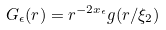Convert formula to latex. <formula><loc_0><loc_0><loc_500><loc_500>G _ { \epsilon } ( r ) = r ^ { - 2 x _ { \epsilon } } g ( r / \xi _ { 2 } )</formula> 